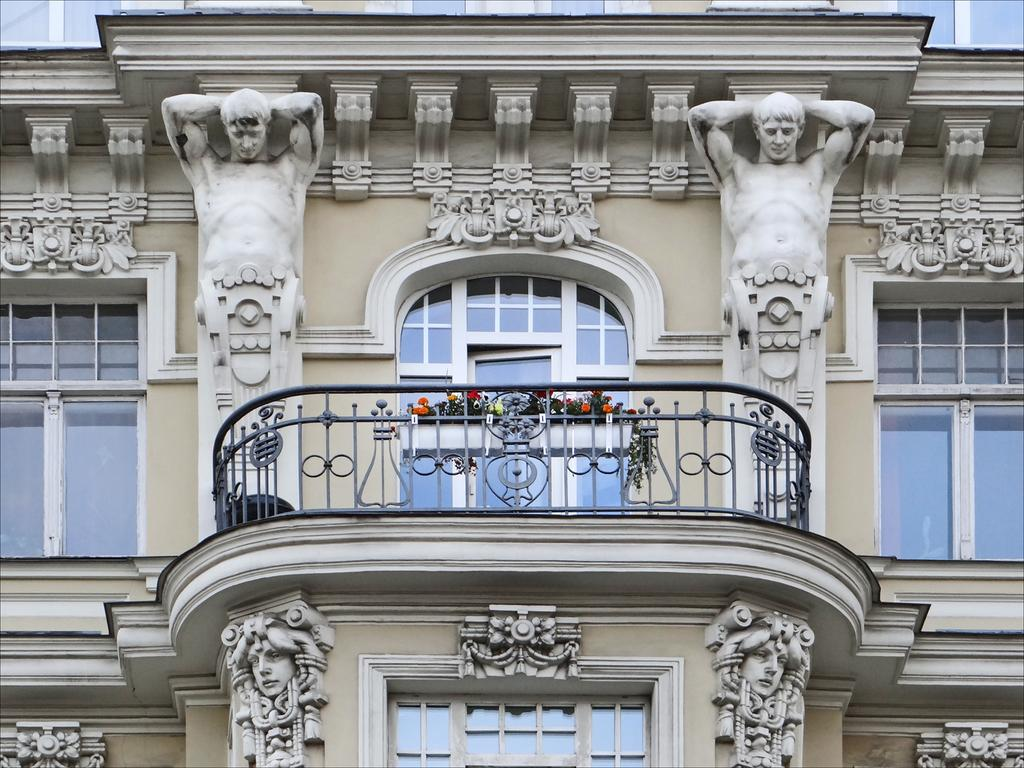What type of structure is visible in the image? There is a building in the image. Are there any other objects or features in the image besides the building? Yes, there are 2 sculptures in the image. What can be observed about the building's design? The building has windows. What type of vegetation is present in the image? There are colorful flowers in the image. Can you describe how the earth is depicted in the image? There is no depiction of the earth in the image; it features a building, sculptures, windows, and flowers. 